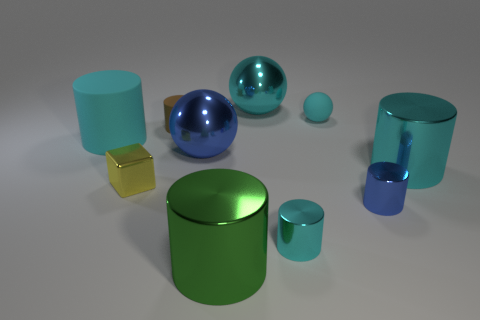How many cyan cylinders must be subtracted to get 1 cyan cylinders? 2 Subtract all brown cubes. How many cyan cylinders are left? 3 Subtract 1 cylinders. How many cylinders are left? 5 Subtract all green cylinders. How many cylinders are left? 5 Subtract all large cyan cylinders. How many cylinders are left? 4 Subtract all blue cylinders. Subtract all yellow cubes. How many cylinders are left? 5 Subtract all blocks. How many objects are left? 9 Subtract all big metal cylinders. Subtract all spheres. How many objects are left? 5 Add 2 green cylinders. How many green cylinders are left? 3 Add 3 cyan rubber balls. How many cyan rubber balls exist? 4 